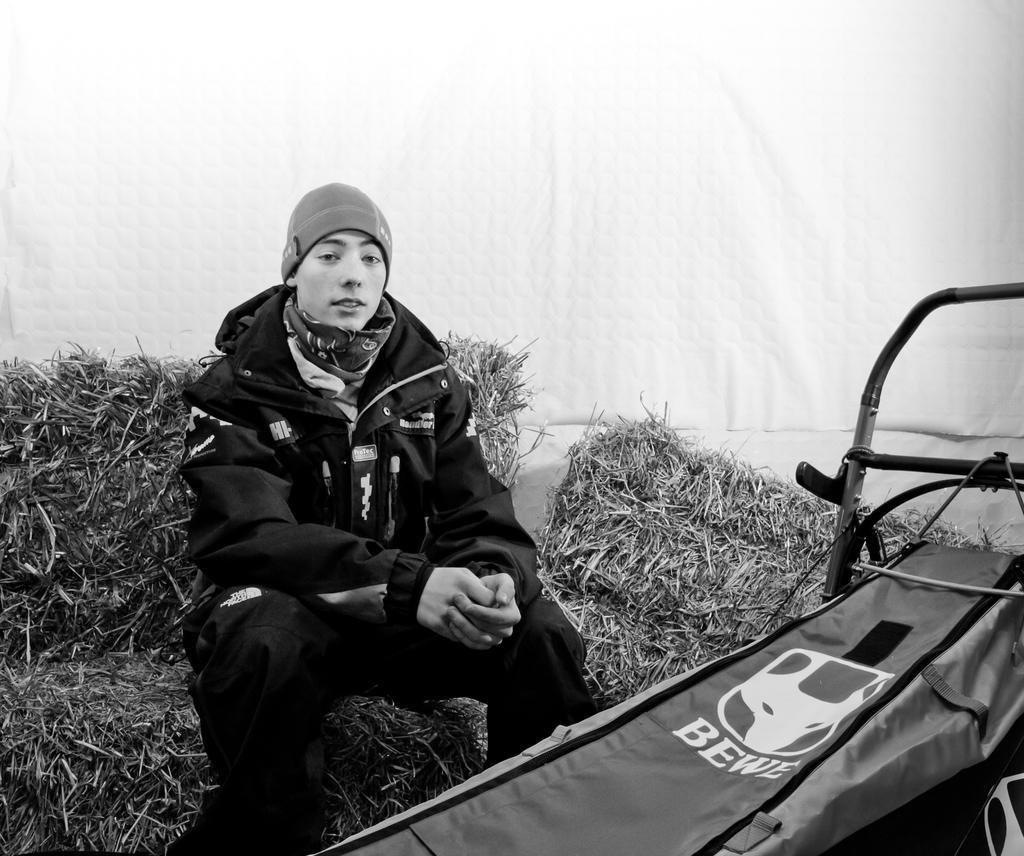Please provide a concise description of this image. In this image in the front there is a bag with some text written on it and in the center there is a person sitting on the grass. In the background there is an object which is white in colour. 